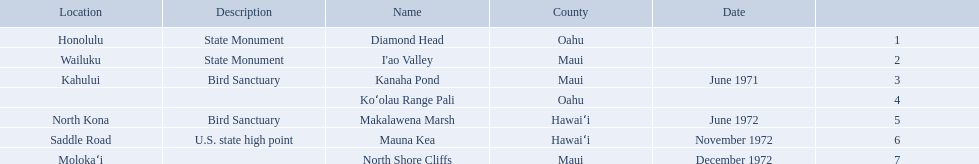Which national natural landmarks in hawaii are in oahu county? Diamond Head, Koʻolau Range Pali. Of these landmarks, which one is listed without a location? Koʻolau Range Pali. 